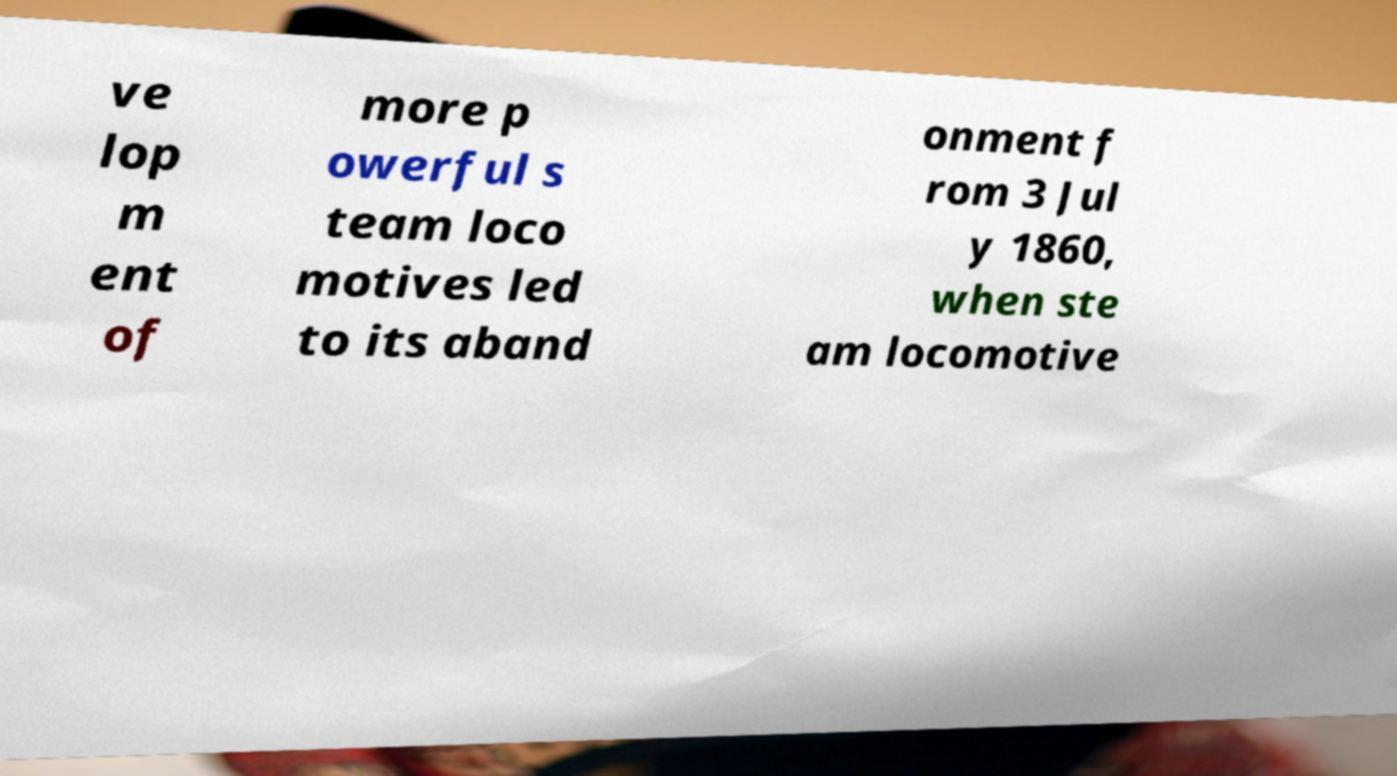For documentation purposes, I need the text within this image transcribed. Could you provide that? ve lop m ent of more p owerful s team loco motives led to its aband onment f rom 3 Jul y 1860, when ste am locomotive 